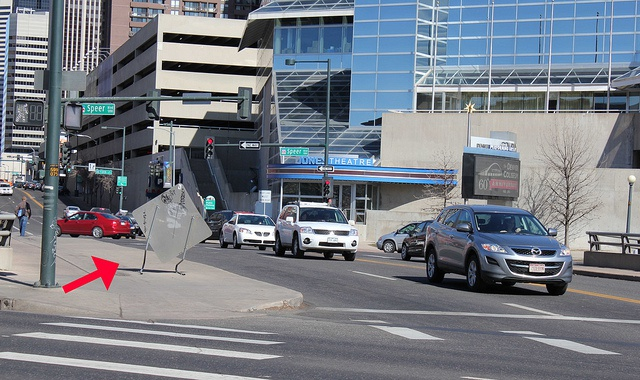Describe the objects in this image and their specific colors. I can see car in lightgray, black, gray, and blue tones, car in lightgray, white, black, gray, and darkgray tones, car in lightgray, brown, maroon, black, and gray tones, car in lightgray, white, black, gray, and darkgray tones, and bench in lightgray, gray, darkgray, and black tones in this image. 